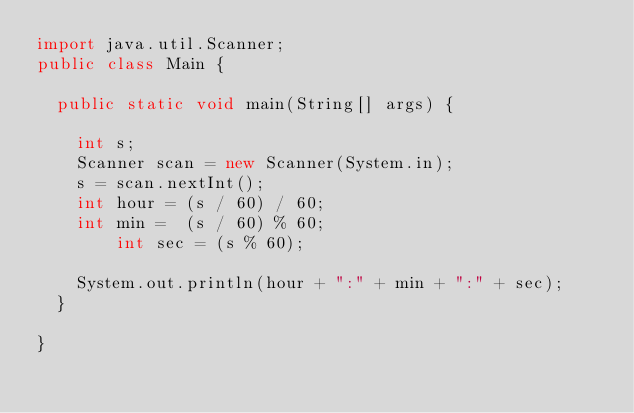Convert code to text. <code><loc_0><loc_0><loc_500><loc_500><_Java_>import java.util.Scanner;
public class Main {

	public static void main(String[] args) {

		int s;
		Scanner scan = new Scanner(System.in);
		s = scan.nextInt();
		int hour = (s / 60) / 60;
		int min =  (s / 60) % 60;
        int sec = (s % 60);

		System.out.println(hour + ":" + min + ":" + sec);
	}

}</code> 